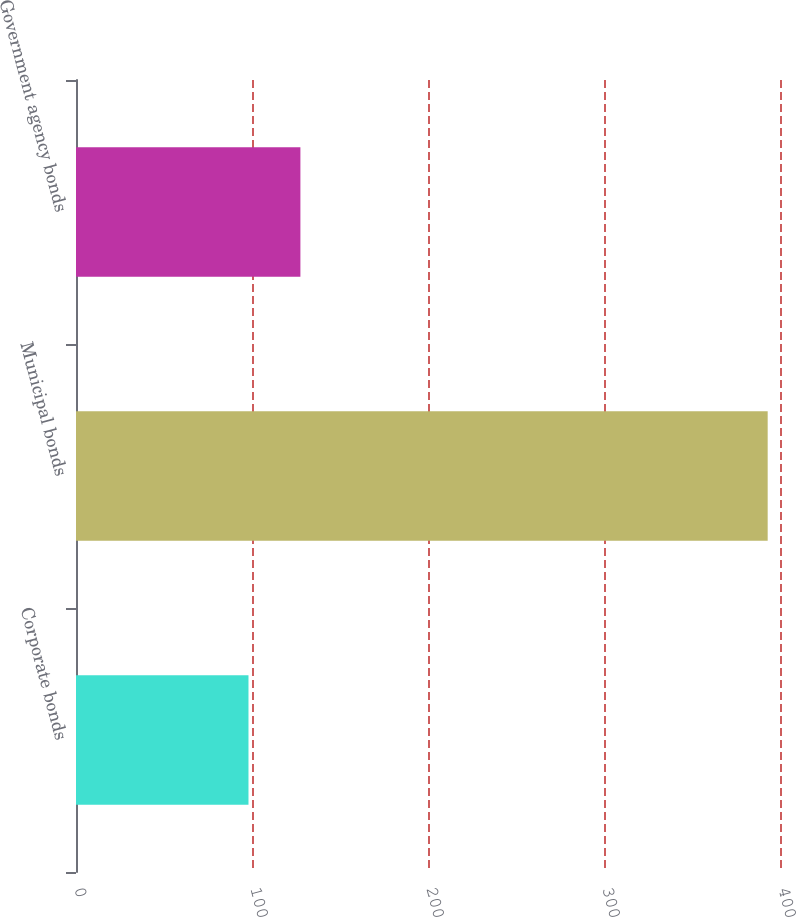Convert chart. <chart><loc_0><loc_0><loc_500><loc_500><bar_chart><fcel>Corporate bonds<fcel>Municipal bonds<fcel>Government agency bonds<nl><fcel>98<fcel>393<fcel>127.5<nl></chart> 